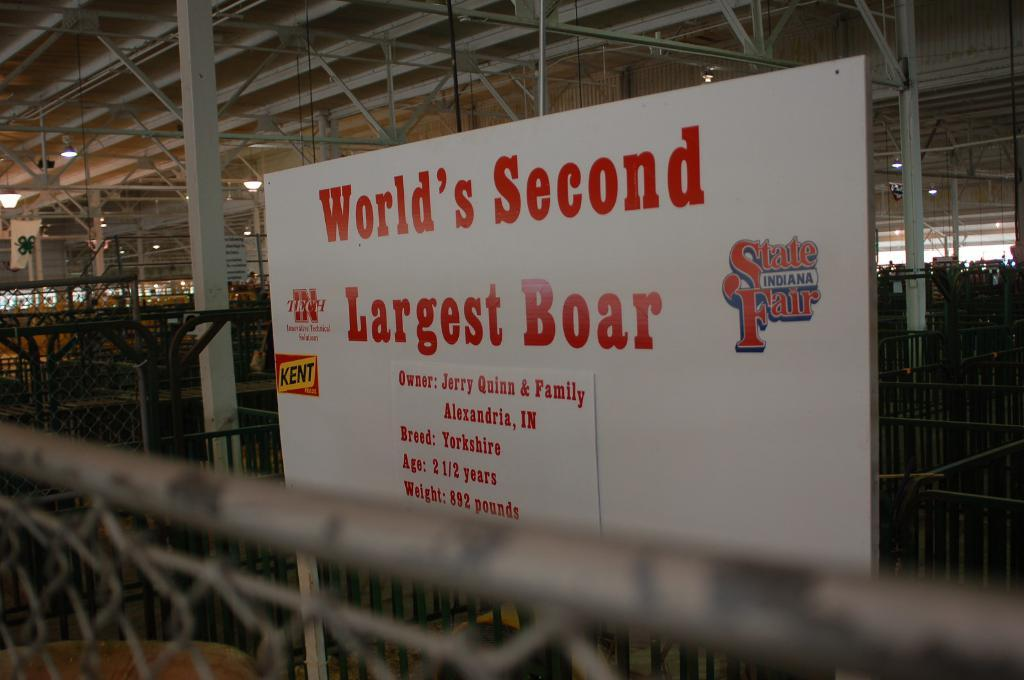<image>
Share a concise interpretation of the image provided. A red and white sign advertises the World's Second Largest Boar. 